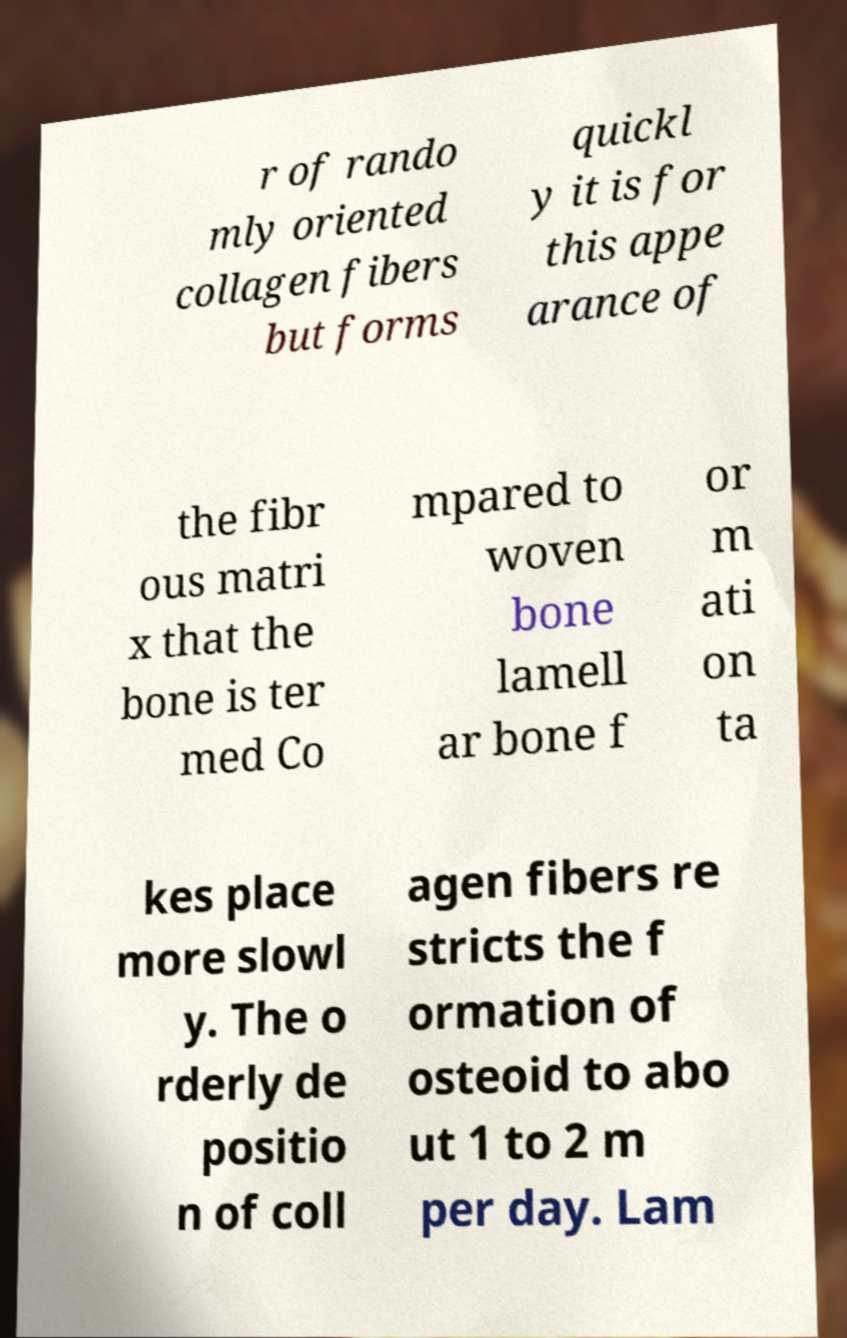Could you extract and type out the text from this image? r of rando mly oriented collagen fibers but forms quickl y it is for this appe arance of the fibr ous matri x that the bone is ter med Co mpared to woven bone lamell ar bone f or m ati on ta kes place more slowl y. The o rderly de positio n of coll agen fibers re stricts the f ormation of osteoid to abo ut 1 to 2 m per day. Lam 